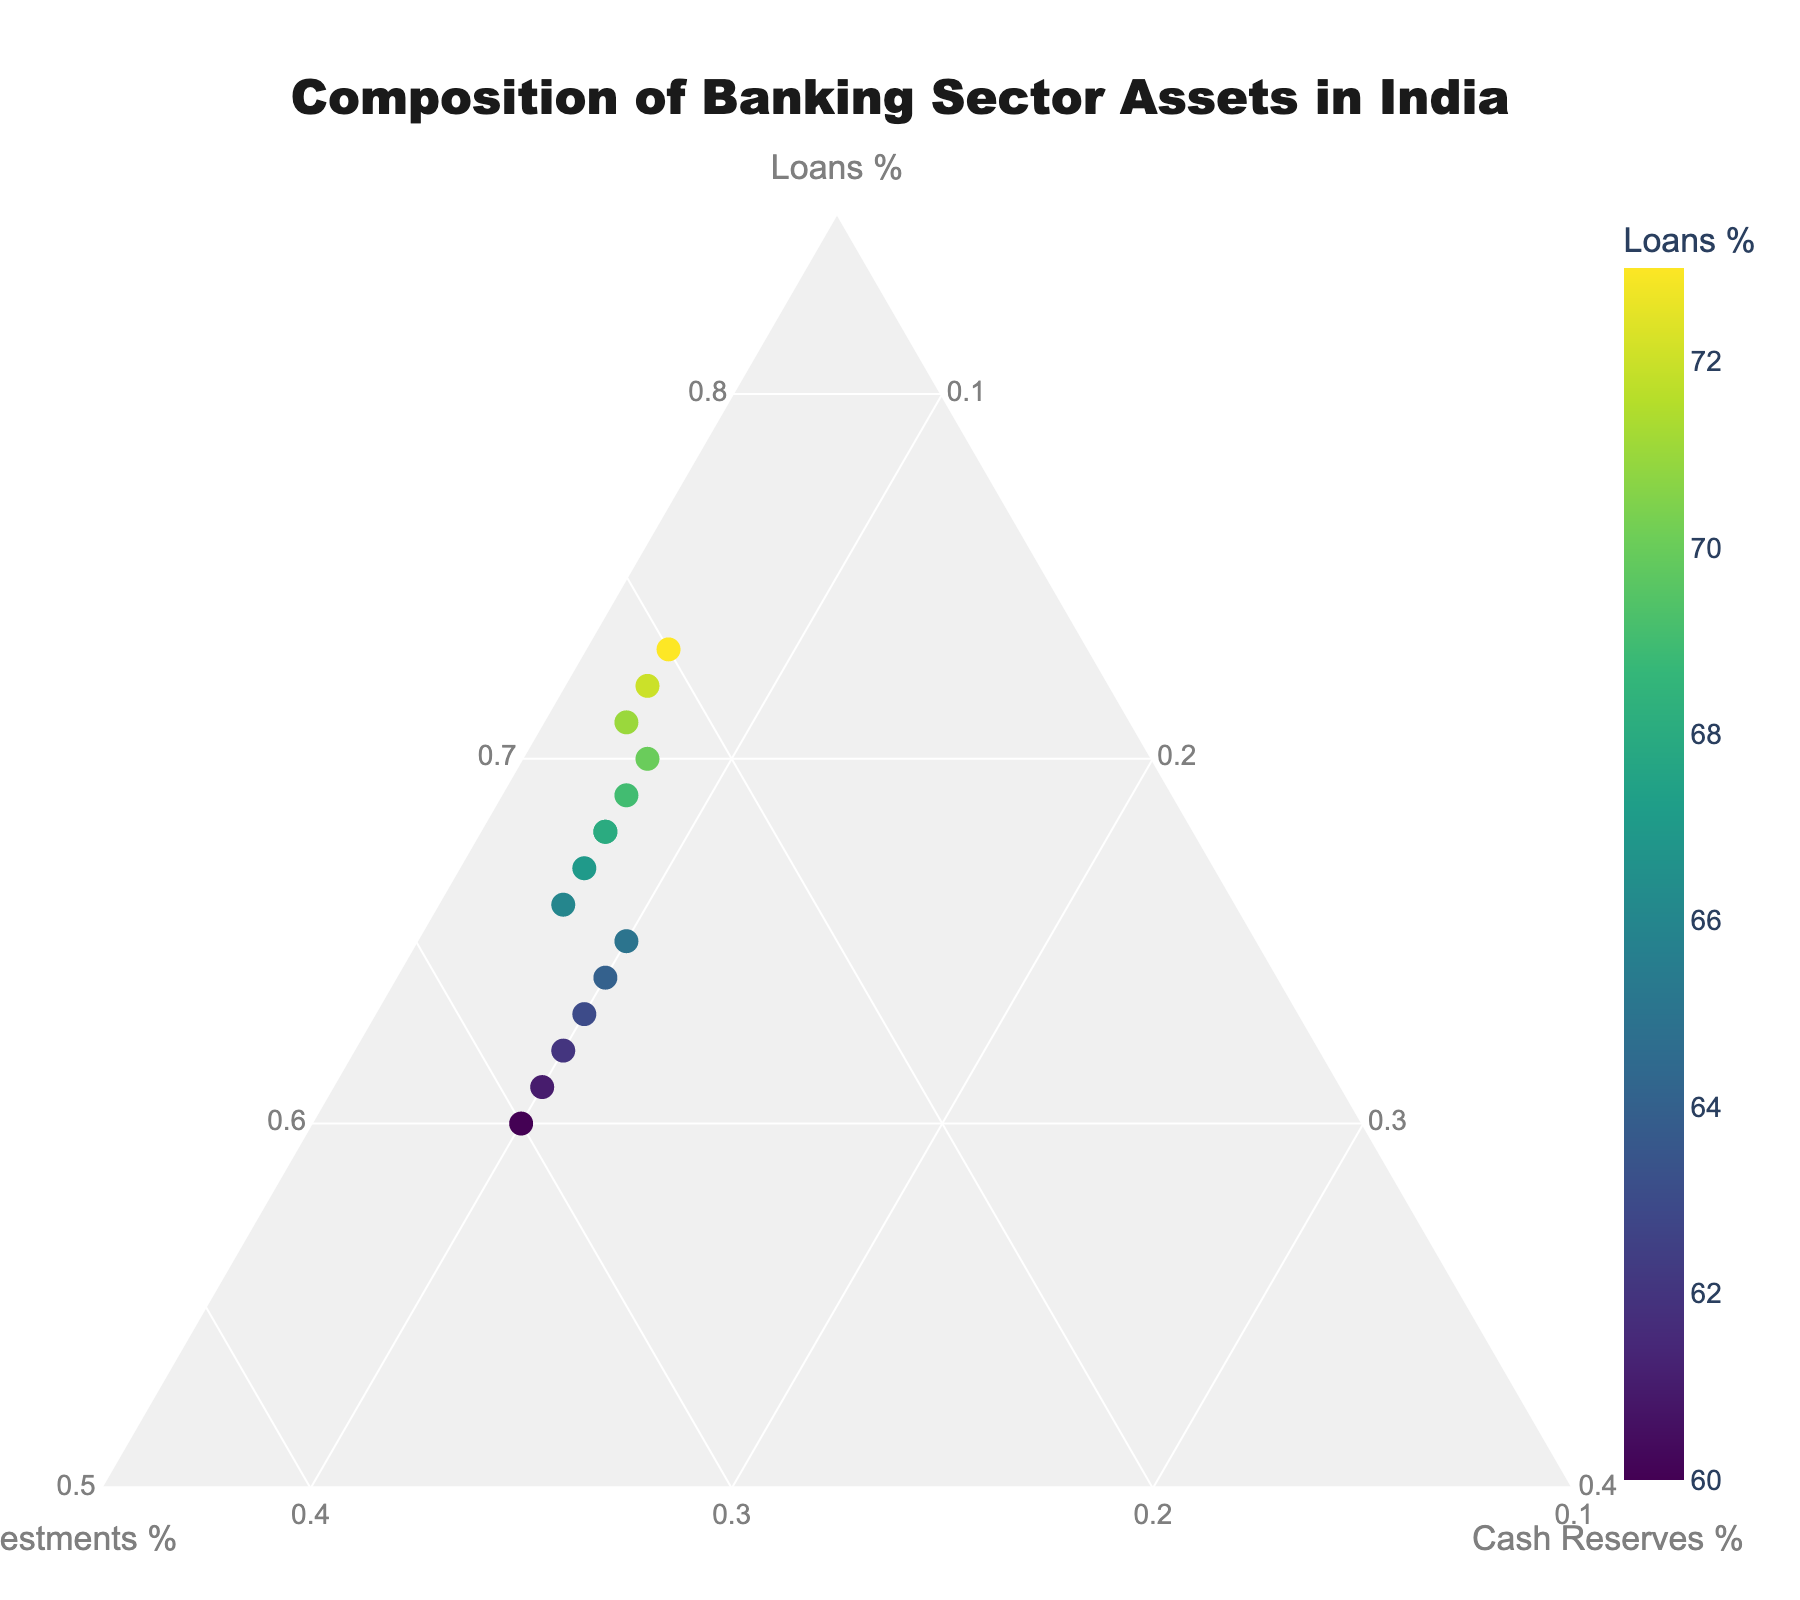What's the title of the plot? The title can be found at the top of the plot. It is usually rendered in a larger and bold font. The title of the plot is "Composition of Banking Sector Assets in India".
Answer: Composition of Banking Sector Assets in India Which three banks have the highest percentage of loans? By looking at the position of the markers and the color intensity corresponding to the percentage of loans, we can identify the banks with the highest percentages of loans. The three banks with the highest percentage of loans are Bandhan Bank (73%), IndusInd Bank (72%), and Kotak Mahindra Bank (71%).
Answer: Bandhan Bank, IndusInd Bank, Kotak Mahindra Bank How many banks have a loans percentage above 65%? To determine this, we count the number of markers with a percentage value greater than 65% in the 'Loans' axis. There are 11 banks with a loans percentage above 65%.
Answer: 11 Which bank has the highest percentage of cash reserves? We can find this bank by identifying the markers with the highest positions along the 'Cash Reserves' axis. The bank with the highest percentage of cash reserves is IDBI Bank, with 10%.
Answer: IDBI Bank What is the combined percentage of loans and investments for HDFC Bank? Add the percentages of loans and investments for HDFC Bank. That is 70% (loans) + 22% (investments) = 92%. Therefore, the combined percentage is 92%.
Answer: 92% Which bank has an equal percentage of loans and cash reserves? Based on the data points, we see that no bank has an equal percentage of loans and cash reserves, as the respective markers show variations for all points. Thus, no bank has an equal percentage in these categories.
Answer: None What is the average percentage of investments across all banks? To find this, we sum the percentages of investments for all banks and then divide by the number of banks. The sum is: 25+22+24+28+26+23+27+29+21+22+25+30+26+24+20 = 342. The number of banks is 15. So, the average percentage is 342/15 = 22.8%.
Answer: 22.8% Compare the percentage of loans between Yes Bank and Axis Bank. Which bank has a higher percentage? Based on the figure, Yes Bank has a loans percentage of 67%, while Axis Bank has 69%. From this comparison, Axis Bank has a higher percentage of loans than Yes Bank.
Answer: Axis Bank Which bank has the lowest percentage of investments? We need to identify the marker closest to the base of the 'Investments' axis. The bank with the lowest percentage of investments is Bandhan Bank, with 20%.
Answer: Bandhan Bank 